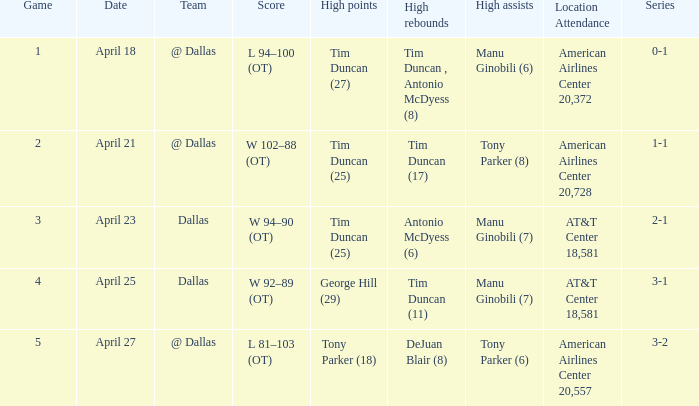With a 0-1 series, who holds the maximum quantity of assists? Manu Ginobili (6). 